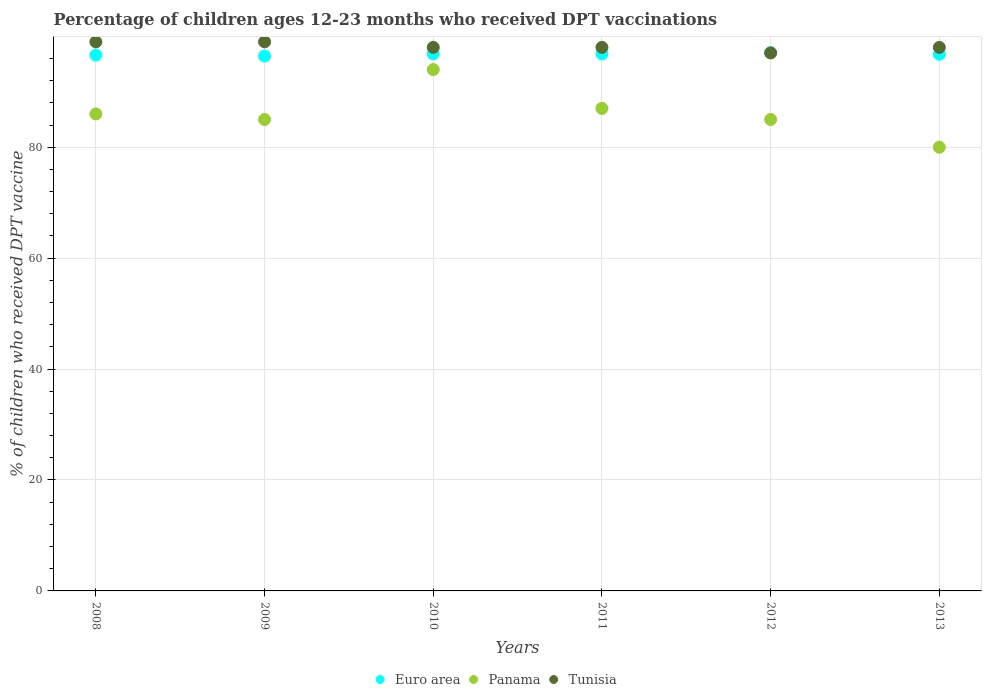Is the number of dotlines equal to the number of legend labels?
Make the answer very short. Yes. What is the percentage of children who received DPT vaccination in Tunisia in 2012?
Give a very brief answer. 97. Across all years, what is the maximum percentage of children who received DPT vaccination in Euro area?
Give a very brief answer. 97.06. Across all years, what is the minimum percentage of children who received DPT vaccination in Euro area?
Ensure brevity in your answer.  96.44. What is the total percentage of children who received DPT vaccination in Tunisia in the graph?
Make the answer very short. 589. What is the difference between the percentage of children who received DPT vaccination in Tunisia in 2008 and that in 2011?
Your response must be concise. 1. What is the difference between the percentage of children who received DPT vaccination in Tunisia in 2012 and the percentage of children who received DPT vaccination in Panama in 2009?
Your answer should be very brief. 12. What is the average percentage of children who received DPT vaccination in Panama per year?
Your answer should be very brief. 86.17. In how many years, is the percentage of children who received DPT vaccination in Tunisia greater than 44 %?
Keep it short and to the point. 6. What is the ratio of the percentage of children who received DPT vaccination in Euro area in 2010 to that in 2012?
Offer a terse response. 1. Is the percentage of children who received DPT vaccination in Euro area in 2008 less than that in 2012?
Provide a succinct answer. Yes. Is the difference between the percentage of children who received DPT vaccination in Panama in 2010 and 2012 greater than the difference between the percentage of children who received DPT vaccination in Tunisia in 2010 and 2012?
Your answer should be very brief. Yes. What is the difference between the highest and the second highest percentage of children who received DPT vaccination in Tunisia?
Provide a succinct answer. 0. What is the difference between the highest and the lowest percentage of children who received DPT vaccination in Panama?
Your response must be concise. 14. Does the percentage of children who received DPT vaccination in Panama monotonically increase over the years?
Give a very brief answer. No. Is the percentage of children who received DPT vaccination in Tunisia strictly greater than the percentage of children who received DPT vaccination in Euro area over the years?
Your response must be concise. No. Is the percentage of children who received DPT vaccination in Euro area strictly less than the percentage of children who received DPT vaccination in Tunisia over the years?
Provide a short and direct response. No. How many years are there in the graph?
Offer a terse response. 6. What is the difference between two consecutive major ticks on the Y-axis?
Offer a terse response. 20. Does the graph contain any zero values?
Ensure brevity in your answer.  No. What is the title of the graph?
Offer a very short reply. Percentage of children ages 12-23 months who received DPT vaccinations. What is the label or title of the X-axis?
Give a very brief answer. Years. What is the label or title of the Y-axis?
Provide a short and direct response. % of children who received DPT vaccine. What is the % of children who received DPT vaccine in Euro area in 2008?
Offer a terse response. 96.61. What is the % of children who received DPT vaccine of Tunisia in 2008?
Your answer should be compact. 99. What is the % of children who received DPT vaccine in Euro area in 2009?
Your answer should be very brief. 96.44. What is the % of children who received DPT vaccine of Panama in 2009?
Keep it short and to the point. 85. What is the % of children who received DPT vaccine in Euro area in 2010?
Your answer should be compact. 96.84. What is the % of children who received DPT vaccine in Panama in 2010?
Provide a succinct answer. 94. What is the % of children who received DPT vaccine of Euro area in 2011?
Your response must be concise. 96.82. What is the % of children who received DPT vaccine of Euro area in 2012?
Ensure brevity in your answer.  97.06. What is the % of children who received DPT vaccine of Tunisia in 2012?
Keep it short and to the point. 97. What is the % of children who received DPT vaccine in Euro area in 2013?
Your response must be concise. 96.76. What is the % of children who received DPT vaccine of Tunisia in 2013?
Your response must be concise. 98. Across all years, what is the maximum % of children who received DPT vaccine in Euro area?
Make the answer very short. 97.06. Across all years, what is the maximum % of children who received DPT vaccine of Panama?
Offer a terse response. 94. Across all years, what is the maximum % of children who received DPT vaccine in Tunisia?
Make the answer very short. 99. Across all years, what is the minimum % of children who received DPT vaccine in Euro area?
Your answer should be compact. 96.44. Across all years, what is the minimum % of children who received DPT vaccine in Tunisia?
Ensure brevity in your answer.  97. What is the total % of children who received DPT vaccine in Euro area in the graph?
Give a very brief answer. 580.53. What is the total % of children who received DPT vaccine of Panama in the graph?
Provide a short and direct response. 517. What is the total % of children who received DPT vaccine of Tunisia in the graph?
Give a very brief answer. 589. What is the difference between the % of children who received DPT vaccine of Euro area in 2008 and that in 2009?
Your answer should be very brief. 0.17. What is the difference between the % of children who received DPT vaccine in Euro area in 2008 and that in 2010?
Make the answer very short. -0.23. What is the difference between the % of children who received DPT vaccine in Panama in 2008 and that in 2010?
Offer a very short reply. -8. What is the difference between the % of children who received DPT vaccine of Euro area in 2008 and that in 2011?
Offer a very short reply. -0.21. What is the difference between the % of children who received DPT vaccine in Panama in 2008 and that in 2011?
Your response must be concise. -1. What is the difference between the % of children who received DPT vaccine in Tunisia in 2008 and that in 2011?
Ensure brevity in your answer.  1. What is the difference between the % of children who received DPT vaccine in Euro area in 2008 and that in 2012?
Make the answer very short. -0.45. What is the difference between the % of children who received DPT vaccine in Panama in 2008 and that in 2012?
Provide a short and direct response. 1. What is the difference between the % of children who received DPT vaccine of Euro area in 2008 and that in 2013?
Give a very brief answer. -0.15. What is the difference between the % of children who received DPT vaccine of Panama in 2008 and that in 2013?
Your answer should be very brief. 6. What is the difference between the % of children who received DPT vaccine in Tunisia in 2008 and that in 2013?
Your response must be concise. 1. What is the difference between the % of children who received DPT vaccine in Euro area in 2009 and that in 2010?
Your response must be concise. -0.4. What is the difference between the % of children who received DPT vaccine in Tunisia in 2009 and that in 2010?
Offer a terse response. 1. What is the difference between the % of children who received DPT vaccine in Euro area in 2009 and that in 2011?
Provide a succinct answer. -0.38. What is the difference between the % of children who received DPT vaccine in Euro area in 2009 and that in 2012?
Offer a terse response. -0.62. What is the difference between the % of children who received DPT vaccine in Euro area in 2009 and that in 2013?
Ensure brevity in your answer.  -0.32. What is the difference between the % of children who received DPT vaccine in Euro area in 2010 and that in 2011?
Ensure brevity in your answer.  0.01. What is the difference between the % of children who received DPT vaccine in Tunisia in 2010 and that in 2011?
Keep it short and to the point. 0. What is the difference between the % of children who received DPT vaccine of Euro area in 2010 and that in 2012?
Give a very brief answer. -0.22. What is the difference between the % of children who received DPT vaccine in Euro area in 2010 and that in 2013?
Keep it short and to the point. 0.07. What is the difference between the % of children who received DPT vaccine in Panama in 2010 and that in 2013?
Provide a short and direct response. 14. What is the difference between the % of children who received DPT vaccine of Euro area in 2011 and that in 2012?
Keep it short and to the point. -0.24. What is the difference between the % of children who received DPT vaccine of Euro area in 2011 and that in 2013?
Offer a very short reply. 0.06. What is the difference between the % of children who received DPT vaccine in Euro area in 2012 and that in 2013?
Offer a terse response. 0.3. What is the difference between the % of children who received DPT vaccine of Tunisia in 2012 and that in 2013?
Offer a terse response. -1. What is the difference between the % of children who received DPT vaccine of Euro area in 2008 and the % of children who received DPT vaccine of Panama in 2009?
Provide a short and direct response. 11.61. What is the difference between the % of children who received DPT vaccine in Euro area in 2008 and the % of children who received DPT vaccine in Tunisia in 2009?
Make the answer very short. -2.39. What is the difference between the % of children who received DPT vaccine of Euro area in 2008 and the % of children who received DPT vaccine of Panama in 2010?
Your answer should be compact. 2.61. What is the difference between the % of children who received DPT vaccine in Euro area in 2008 and the % of children who received DPT vaccine in Tunisia in 2010?
Your answer should be very brief. -1.39. What is the difference between the % of children who received DPT vaccine of Euro area in 2008 and the % of children who received DPT vaccine of Panama in 2011?
Make the answer very short. 9.61. What is the difference between the % of children who received DPT vaccine of Euro area in 2008 and the % of children who received DPT vaccine of Tunisia in 2011?
Give a very brief answer. -1.39. What is the difference between the % of children who received DPT vaccine of Euro area in 2008 and the % of children who received DPT vaccine of Panama in 2012?
Provide a short and direct response. 11.61. What is the difference between the % of children who received DPT vaccine of Euro area in 2008 and the % of children who received DPT vaccine of Tunisia in 2012?
Provide a short and direct response. -0.39. What is the difference between the % of children who received DPT vaccine of Euro area in 2008 and the % of children who received DPT vaccine of Panama in 2013?
Give a very brief answer. 16.61. What is the difference between the % of children who received DPT vaccine of Euro area in 2008 and the % of children who received DPT vaccine of Tunisia in 2013?
Offer a very short reply. -1.39. What is the difference between the % of children who received DPT vaccine of Euro area in 2009 and the % of children who received DPT vaccine of Panama in 2010?
Provide a short and direct response. 2.44. What is the difference between the % of children who received DPT vaccine in Euro area in 2009 and the % of children who received DPT vaccine in Tunisia in 2010?
Give a very brief answer. -1.56. What is the difference between the % of children who received DPT vaccine in Panama in 2009 and the % of children who received DPT vaccine in Tunisia in 2010?
Your response must be concise. -13. What is the difference between the % of children who received DPT vaccine of Euro area in 2009 and the % of children who received DPT vaccine of Panama in 2011?
Give a very brief answer. 9.44. What is the difference between the % of children who received DPT vaccine of Euro area in 2009 and the % of children who received DPT vaccine of Tunisia in 2011?
Keep it short and to the point. -1.56. What is the difference between the % of children who received DPT vaccine of Panama in 2009 and the % of children who received DPT vaccine of Tunisia in 2011?
Keep it short and to the point. -13. What is the difference between the % of children who received DPT vaccine in Euro area in 2009 and the % of children who received DPT vaccine in Panama in 2012?
Your response must be concise. 11.44. What is the difference between the % of children who received DPT vaccine in Euro area in 2009 and the % of children who received DPT vaccine in Tunisia in 2012?
Provide a succinct answer. -0.56. What is the difference between the % of children who received DPT vaccine in Euro area in 2009 and the % of children who received DPT vaccine in Panama in 2013?
Give a very brief answer. 16.44. What is the difference between the % of children who received DPT vaccine in Euro area in 2009 and the % of children who received DPT vaccine in Tunisia in 2013?
Ensure brevity in your answer.  -1.56. What is the difference between the % of children who received DPT vaccine of Euro area in 2010 and the % of children who received DPT vaccine of Panama in 2011?
Provide a short and direct response. 9.84. What is the difference between the % of children who received DPT vaccine in Euro area in 2010 and the % of children who received DPT vaccine in Tunisia in 2011?
Offer a very short reply. -1.16. What is the difference between the % of children who received DPT vaccine of Panama in 2010 and the % of children who received DPT vaccine of Tunisia in 2011?
Keep it short and to the point. -4. What is the difference between the % of children who received DPT vaccine of Euro area in 2010 and the % of children who received DPT vaccine of Panama in 2012?
Provide a short and direct response. 11.84. What is the difference between the % of children who received DPT vaccine in Euro area in 2010 and the % of children who received DPT vaccine in Tunisia in 2012?
Make the answer very short. -0.16. What is the difference between the % of children who received DPT vaccine of Euro area in 2010 and the % of children who received DPT vaccine of Panama in 2013?
Make the answer very short. 16.84. What is the difference between the % of children who received DPT vaccine in Euro area in 2010 and the % of children who received DPT vaccine in Tunisia in 2013?
Your answer should be very brief. -1.16. What is the difference between the % of children who received DPT vaccine in Panama in 2010 and the % of children who received DPT vaccine in Tunisia in 2013?
Provide a succinct answer. -4. What is the difference between the % of children who received DPT vaccine in Euro area in 2011 and the % of children who received DPT vaccine in Panama in 2012?
Your answer should be compact. 11.82. What is the difference between the % of children who received DPT vaccine in Euro area in 2011 and the % of children who received DPT vaccine in Tunisia in 2012?
Offer a very short reply. -0.18. What is the difference between the % of children who received DPT vaccine of Panama in 2011 and the % of children who received DPT vaccine of Tunisia in 2012?
Ensure brevity in your answer.  -10. What is the difference between the % of children who received DPT vaccine in Euro area in 2011 and the % of children who received DPT vaccine in Panama in 2013?
Your response must be concise. 16.82. What is the difference between the % of children who received DPT vaccine of Euro area in 2011 and the % of children who received DPT vaccine of Tunisia in 2013?
Make the answer very short. -1.18. What is the difference between the % of children who received DPT vaccine of Panama in 2011 and the % of children who received DPT vaccine of Tunisia in 2013?
Make the answer very short. -11. What is the difference between the % of children who received DPT vaccine in Euro area in 2012 and the % of children who received DPT vaccine in Panama in 2013?
Your response must be concise. 17.06. What is the difference between the % of children who received DPT vaccine in Euro area in 2012 and the % of children who received DPT vaccine in Tunisia in 2013?
Offer a terse response. -0.94. What is the average % of children who received DPT vaccine in Euro area per year?
Your answer should be compact. 96.76. What is the average % of children who received DPT vaccine in Panama per year?
Make the answer very short. 86.17. What is the average % of children who received DPT vaccine of Tunisia per year?
Your answer should be compact. 98.17. In the year 2008, what is the difference between the % of children who received DPT vaccine in Euro area and % of children who received DPT vaccine in Panama?
Offer a terse response. 10.61. In the year 2008, what is the difference between the % of children who received DPT vaccine in Euro area and % of children who received DPT vaccine in Tunisia?
Provide a short and direct response. -2.39. In the year 2008, what is the difference between the % of children who received DPT vaccine in Panama and % of children who received DPT vaccine in Tunisia?
Provide a succinct answer. -13. In the year 2009, what is the difference between the % of children who received DPT vaccine of Euro area and % of children who received DPT vaccine of Panama?
Make the answer very short. 11.44. In the year 2009, what is the difference between the % of children who received DPT vaccine in Euro area and % of children who received DPT vaccine in Tunisia?
Your response must be concise. -2.56. In the year 2009, what is the difference between the % of children who received DPT vaccine in Panama and % of children who received DPT vaccine in Tunisia?
Make the answer very short. -14. In the year 2010, what is the difference between the % of children who received DPT vaccine in Euro area and % of children who received DPT vaccine in Panama?
Keep it short and to the point. 2.84. In the year 2010, what is the difference between the % of children who received DPT vaccine in Euro area and % of children who received DPT vaccine in Tunisia?
Offer a terse response. -1.16. In the year 2010, what is the difference between the % of children who received DPT vaccine of Panama and % of children who received DPT vaccine of Tunisia?
Provide a short and direct response. -4. In the year 2011, what is the difference between the % of children who received DPT vaccine in Euro area and % of children who received DPT vaccine in Panama?
Your response must be concise. 9.82. In the year 2011, what is the difference between the % of children who received DPT vaccine of Euro area and % of children who received DPT vaccine of Tunisia?
Offer a terse response. -1.18. In the year 2012, what is the difference between the % of children who received DPT vaccine in Euro area and % of children who received DPT vaccine in Panama?
Your answer should be compact. 12.06. In the year 2012, what is the difference between the % of children who received DPT vaccine of Euro area and % of children who received DPT vaccine of Tunisia?
Provide a succinct answer. 0.06. In the year 2012, what is the difference between the % of children who received DPT vaccine in Panama and % of children who received DPT vaccine in Tunisia?
Give a very brief answer. -12. In the year 2013, what is the difference between the % of children who received DPT vaccine of Euro area and % of children who received DPT vaccine of Panama?
Offer a very short reply. 16.76. In the year 2013, what is the difference between the % of children who received DPT vaccine in Euro area and % of children who received DPT vaccine in Tunisia?
Ensure brevity in your answer.  -1.24. What is the ratio of the % of children who received DPT vaccine of Euro area in 2008 to that in 2009?
Offer a very short reply. 1. What is the ratio of the % of children who received DPT vaccine in Panama in 2008 to that in 2009?
Ensure brevity in your answer.  1.01. What is the ratio of the % of children who received DPT vaccine of Panama in 2008 to that in 2010?
Your response must be concise. 0.91. What is the ratio of the % of children who received DPT vaccine in Tunisia in 2008 to that in 2010?
Offer a very short reply. 1.01. What is the ratio of the % of children who received DPT vaccine of Euro area in 2008 to that in 2011?
Ensure brevity in your answer.  1. What is the ratio of the % of children who received DPT vaccine of Tunisia in 2008 to that in 2011?
Your answer should be compact. 1.01. What is the ratio of the % of children who received DPT vaccine of Panama in 2008 to that in 2012?
Ensure brevity in your answer.  1.01. What is the ratio of the % of children who received DPT vaccine of Tunisia in 2008 to that in 2012?
Your response must be concise. 1.02. What is the ratio of the % of children who received DPT vaccine in Euro area in 2008 to that in 2013?
Provide a succinct answer. 1. What is the ratio of the % of children who received DPT vaccine of Panama in 2008 to that in 2013?
Give a very brief answer. 1.07. What is the ratio of the % of children who received DPT vaccine in Tunisia in 2008 to that in 2013?
Offer a terse response. 1.01. What is the ratio of the % of children who received DPT vaccine of Panama in 2009 to that in 2010?
Offer a very short reply. 0.9. What is the ratio of the % of children who received DPT vaccine of Tunisia in 2009 to that in 2010?
Ensure brevity in your answer.  1.01. What is the ratio of the % of children who received DPT vaccine in Panama in 2009 to that in 2011?
Provide a short and direct response. 0.98. What is the ratio of the % of children who received DPT vaccine of Tunisia in 2009 to that in 2011?
Keep it short and to the point. 1.01. What is the ratio of the % of children who received DPT vaccine of Euro area in 2009 to that in 2012?
Provide a short and direct response. 0.99. What is the ratio of the % of children who received DPT vaccine in Panama in 2009 to that in 2012?
Offer a very short reply. 1. What is the ratio of the % of children who received DPT vaccine of Tunisia in 2009 to that in 2012?
Your response must be concise. 1.02. What is the ratio of the % of children who received DPT vaccine in Euro area in 2009 to that in 2013?
Provide a succinct answer. 1. What is the ratio of the % of children who received DPT vaccine of Tunisia in 2009 to that in 2013?
Your response must be concise. 1.01. What is the ratio of the % of children who received DPT vaccine of Euro area in 2010 to that in 2011?
Give a very brief answer. 1. What is the ratio of the % of children who received DPT vaccine of Panama in 2010 to that in 2011?
Provide a short and direct response. 1.08. What is the ratio of the % of children who received DPT vaccine in Panama in 2010 to that in 2012?
Give a very brief answer. 1.11. What is the ratio of the % of children who received DPT vaccine of Tunisia in 2010 to that in 2012?
Provide a short and direct response. 1.01. What is the ratio of the % of children who received DPT vaccine in Panama in 2010 to that in 2013?
Keep it short and to the point. 1.18. What is the ratio of the % of children who received DPT vaccine of Panama in 2011 to that in 2012?
Provide a short and direct response. 1.02. What is the ratio of the % of children who received DPT vaccine in Tunisia in 2011 to that in 2012?
Provide a succinct answer. 1.01. What is the ratio of the % of children who received DPT vaccine of Euro area in 2011 to that in 2013?
Offer a terse response. 1. What is the ratio of the % of children who received DPT vaccine in Panama in 2011 to that in 2013?
Your answer should be very brief. 1.09. What is the ratio of the % of children who received DPT vaccine of Panama in 2012 to that in 2013?
Offer a very short reply. 1.06. What is the ratio of the % of children who received DPT vaccine in Tunisia in 2012 to that in 2013?
Ensure brevity in your answer.  0.99. What is the difference between the highest and the second highest % of children who received DPT vaccine of Euro area?
Make the answer very short. 0.22. What is the difference between the highest and the second highest % of children who received DPT vaccine in Tunisia?
Give a very brief answer. 0. What is the difference between the highest and the lowest % of children who received DPT vaccine of Euro area?
Your response must be concise. 0.62. 